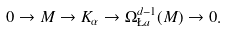Convert formula to latex. <formula><loc_0><loc_0><loc_500><loc_500>0 \to M \to K _ { \alpha } \to \Omega _ { \L a } ^ { d - 1 } ( M ) \to 0 .</formula> 